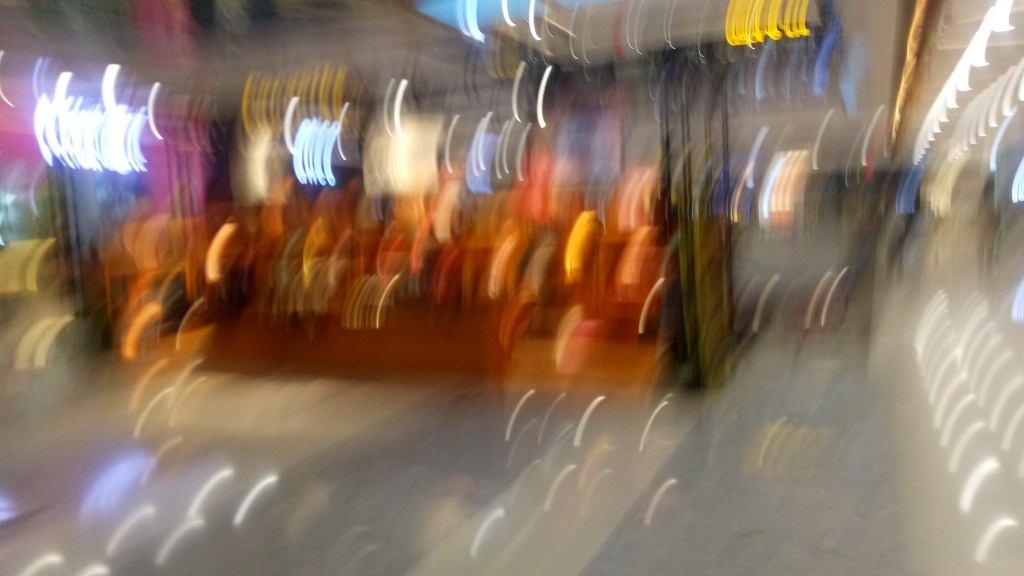What could be the reason for the blurriness in this image? The blurriness in the image could stem from several factors: a slow shutter speed combined with camera movement, a lack of focus, or an intentional artistic technique to convey motion or an abstract effect. How could the quality of this photo be improved? To improve the quality, the photographer could use a faster shutter speed or stabilizing equipment such as a tripod to reduce camera shake. Additionally, ensuring the camera is focused correctly on the desired subject would help in obtaining a clearer image. 